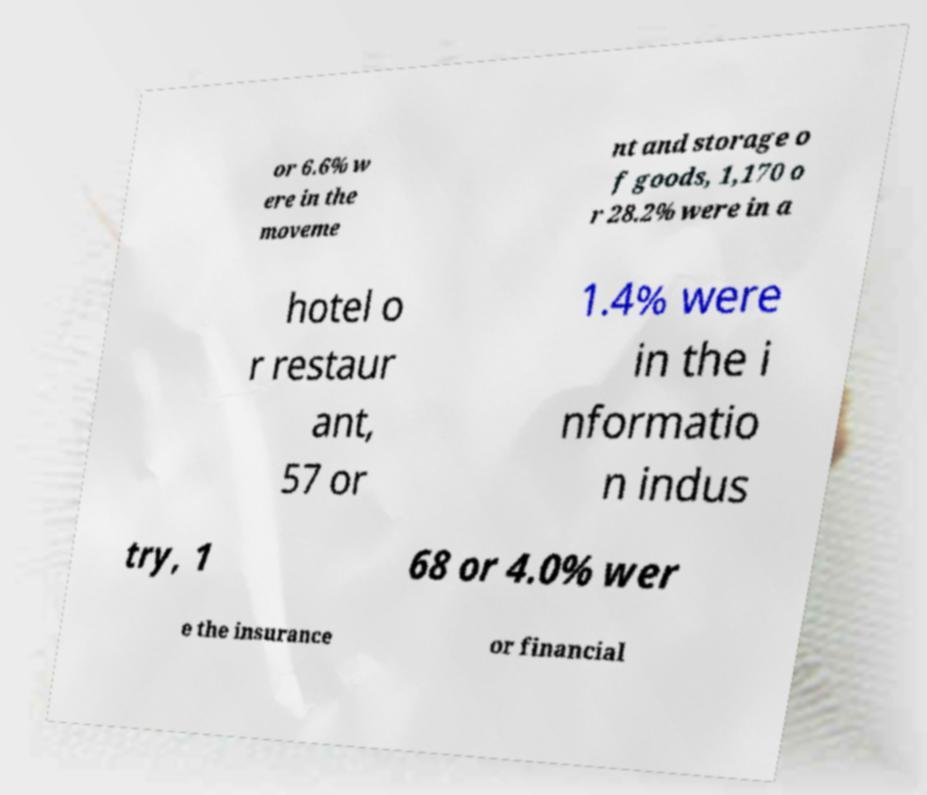What messages or text are displayed in this image? I need them in a readable, typed format. or 6.6% w ere in the moveme nt and storage o f goods, 1,170 o r 28.2% were in a hotel o r restaur ant, 57 or 1.4% were in the i nformatio n indus try, 1 68 or 4.0% wer e the insurance or financial 